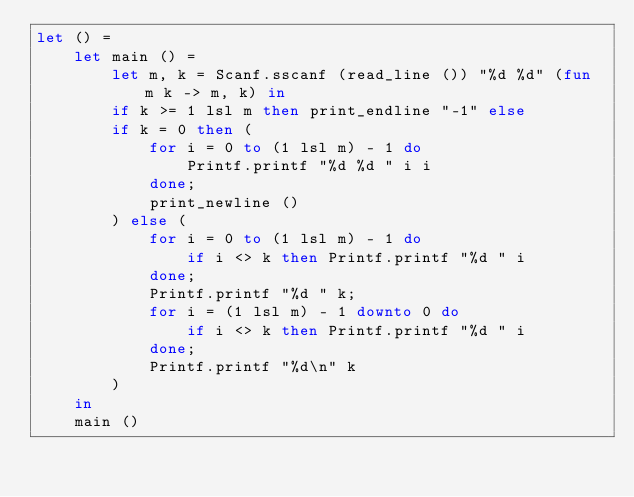Convert code to text. <code><loc_0><loc_0><loc_500><loc_500><_OCaml_>let () =
    let main () =
        let m, k = Scanf.sscanf (read_line ()) "%d %d" (fun m k -> m, k) in
        if k >= 1 lsl m then print_endline "-1" else
        if k = 0 then (
            for i = 0 to (1 lsl m) - 1 do
                Printf.printf "%d %d " i i
            done;
            print_newline ()
        ) else (
            for i = 0 to (1 lsl m) - 1 do
                if i <> k then Printf.printf "%d " i
            done;
            Printf.printf "%d " k;
            for i = (1 lsl m) - 1 downto 0 do
                if i <> k then Printf.printf "%d " i
            done;
            Printf.printf "%d\n" k
        )
    in
    main ()</code> 